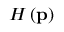<formula> <loc_0><loc_0><loc_500><loc_500>H \left ( p \right )</formula> 